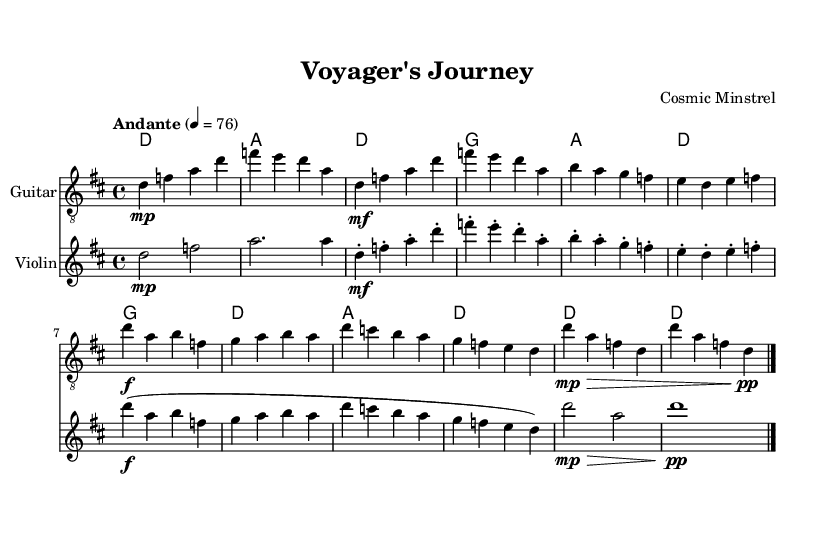What is the key signature of this music? The key signature shows two sharps, indicating it is in D major. This can be found at the beginning of the sheet music, where the sharp symbols are placed on the F and C lines.
Answer: D major What is the time signature of this music? The time signature is shown at the beginning of the piece. It displays 4/4, indicating that there are four beats in each measure and the quarter note gets one beat.
Answer: 4/4 What is the tempo marking for this music? The tempo marking appears above the staff, indicating the speed of the music. In this case, it states "Andante" with a metronome mark of 76, suggesting a moderately slow pace.
Answer: Andante How many measures are there in the chorus? To find the number of measures in the chorus, count each measure within that section explicitly marked in the sheet music. The chorus section includes four measures in total.
Answer: 4 What instruments are featured in this piece? The instruments are listed at the beginning of their respective staves. This piece features a Guitar and a Violin as indicated by their headers.
Answer: Guitar, Violin Which section of the piece has dynamics marked as "f"? The dynamics are marked throughout the sections of the music. The sections where "f" (forte) is marked are found during the Chorus of the composition, highlighting moments of strong sound.
Answer: Chorus 